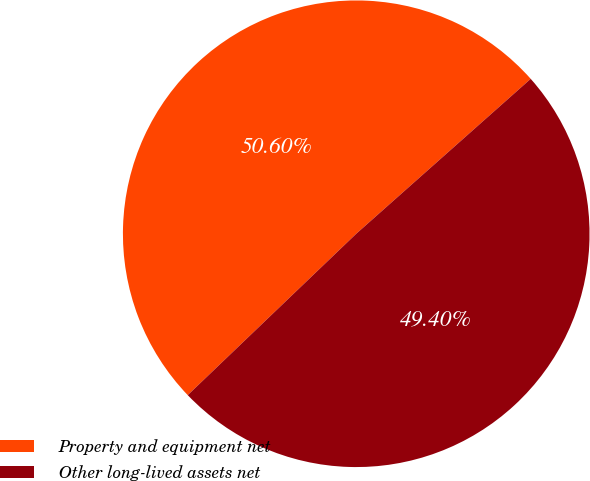Convert chart to OTSL. <chart><loc_0><loc_0><loc_500><loc_500><pie_chart><fcel>Property and equipment net<fcel>Other long-lived assets net<nl><fcel>50.6%<fcel>49.4%<nl></chart> 